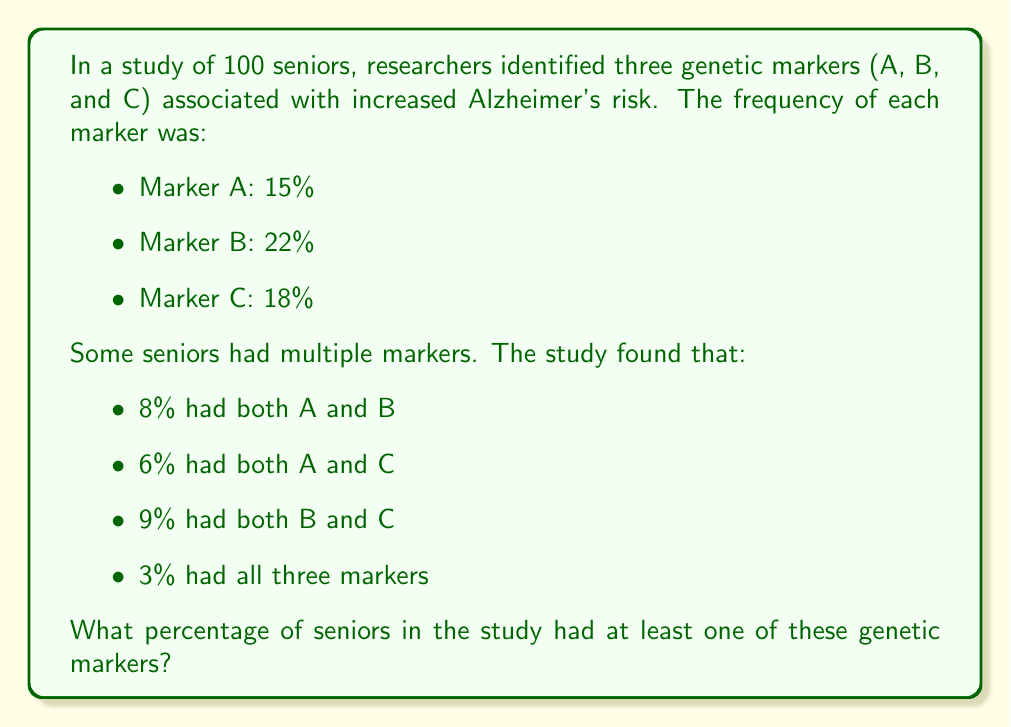Help me with this question. To solve this problem, we'll use the Inclusion-Exclusion Principle. Let's break it down step-by-step:

1) First, let's define our sets:
   A = seniors with marker A
   B = seniors with marker B
   C = seniors with marker C

2) We're given the following information:
   $|A| = 15$, $|B| = 22$, $|C| = 18$
   $|A \cap B| = 8$, $|A \cap C| = 6$, $|B \cap C| = 9$
   $|A \cap B \cap C| = 3$

3) The Inclusion-Exclusion Principle for three sets is:

   $|A \cup B \cup C| = |A| + |B| + |C| - |A \cap B| - |A \cap C| - |B \cap C| + |A \cap B \cap C|$

4) Let's substitute our values:

   $|A \cup B \cup C| = 15 + 22 + 18 - 8 - 6 - 9 + 3$

5) Now we can calculate:

   $|A \cup B \cup C| = 55 - 23 + 3 = 35$

6) This means 35 out of 100 seniors had at least one marker.

7) To convert to a percentage, we divide by 100 and multiply by 100%:

   $\frac{35}{100} * 100\% = 35\%$

Therefore, 35% of seniors in the study had at least one of these genetic markers.
Answer: 35% 